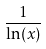Convert formula to latex. <formula><loc_0><loc_0><loc_500><loc_500>\frac { 1 } { \ln ( x ) }</formula> 